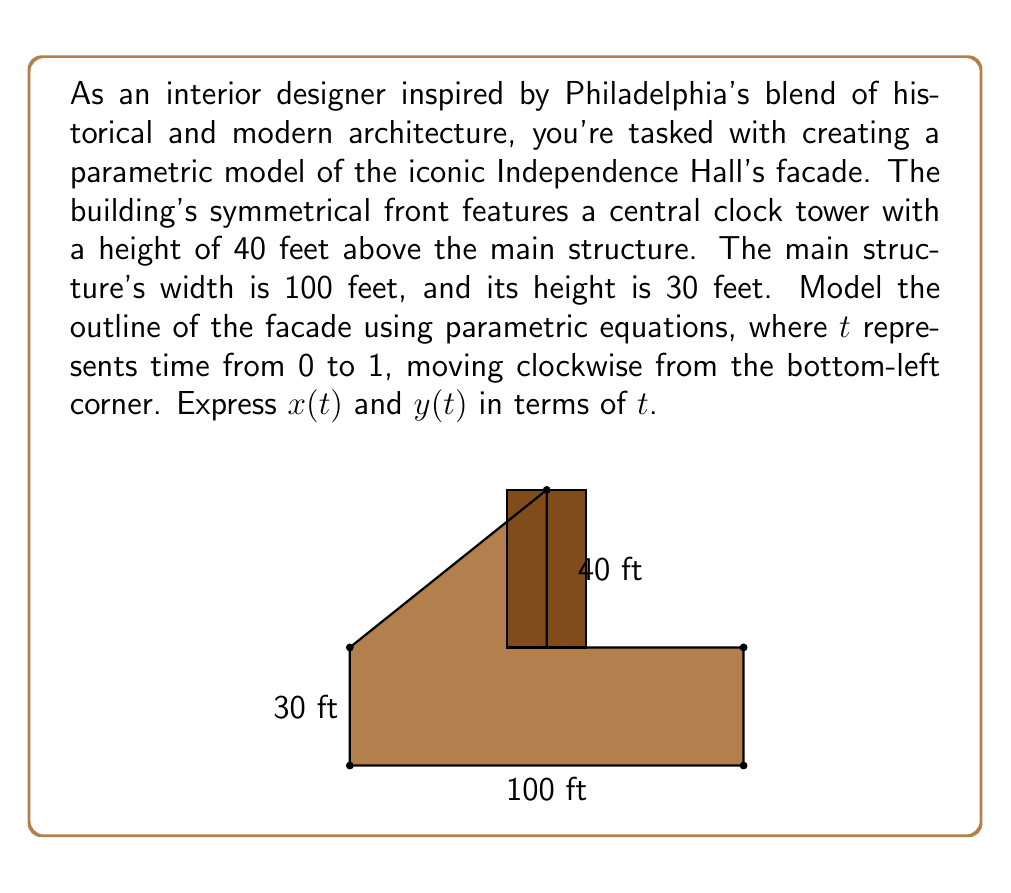What is the answer to this math problem? Let's break down the facade into segments and define parametric equations for each:

1. Bottom edge (0 ≤ t < 0.2):
   $x(t) = 500t$
   $y(t) = 0$

2. Right edge of main structure (0.2 ≤ t < 0.4):
   $x(t) = 100$
   $y(t) = 150(t - 0.2)$

3. Right slope of tower (0.4 ≤ t < 0.6):
   $x(t) = 100 - 250(t - 0.4)$
   $y(t) = 30 + 200(t - 0.4)$

4. Left slope of tower (0.6 ≤ t < 0.8):
   $x(t) = 50 - 250(t - 0.6)$
   $y(t) = 70 - 200(t - 0.6)$

5. Left edge of main structure (0.8 ≤ t ≤ 1):
   $x(t) = 0$
   $y(t) = 30 - 150(t - 0.8)$

To combine these into a single set of piecewise functions:

$$x(t) = \begin{cases}
500t & \text{if } 0 \leq t < 0.2 \\
100 & \text{if } 0.2 \leq t < 0.4 \\
100 - 250(t - 0.4) & \text{if } 0.4 \leq t < 0.6 \\
50 - 250(t - 0.6) & \text{if } 0.6 \leq t < 0.8 \\
0 & \text{if } 0.8 \leq t \leq 1
\end{cases}$$

$$y(t) = \begin{cases}
0 & \text{if } 0 \leq t < 0.2 \\
150(t - 0.2) & \text{if } 0.2 \leq t < 0.4 \\
30 + 200(t - 0.4) & \text{if } 0.4 \leq t < 0.6 \\
70 - 200(t - 0.6) & \text{if } 0.6 \leq t < 0.8 \\
30 - 150(t - 0.8) & \text{if } 0.8 \leq t \leq 1
\end{cases}$$
Answer: $x(t)$ and $y(t)$ are piecewise functions defined over 5 intervals for $0 \leq t \leq 1$ 